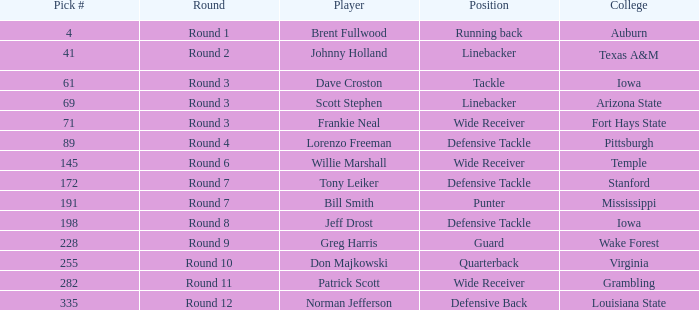What is the sum of pick# for Don Majkowski?3 255.0. 